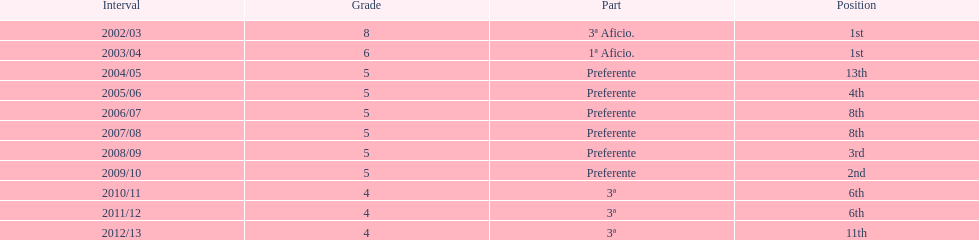How long did the team stay in first place? 2 years. Can you parse all the data within this table? {'header': ['Interval', 'Grade', 'Part', 'Position'], 'rows': [['2002/03', '8', '3ª Aficio.', '1st'], ['2003/04', '6', '1ª Aficio.', '1st'], ['2004/05', '5', 'Preferente', '13th'], ['2005/06', '5', 'Preferente', '4th'], ['2006/07', '5', 'Preferente', '8th'], ['2007/08', '5', 'Preferente', '8th'], ['2008/09', '5', 'Preferente', '3rd'], ['2009/10', '5', 'Preferente', '2nd'], ['2010/11', '4', '3ª', '6th'], ['2011/12', '4', '3ª', '6th'], ['2012/13', '4', '3ª', '11th']]} 